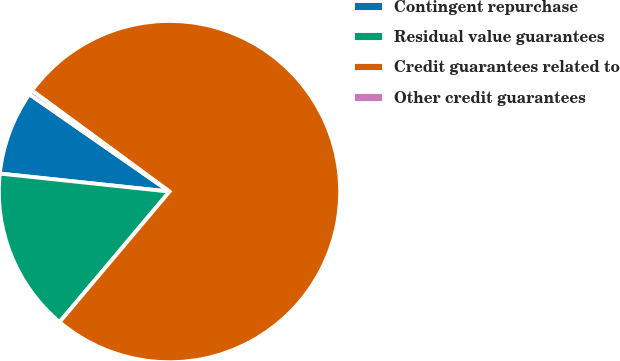Convert chart to OTSL. <chart><loc_0><loc_0><loc_500><loc_500><pie_chart><fcel>Contingent repurchase<fcel>Residual value guarantees<fcel>Credit guarantees related to<fcel>Other credit guarantees<nl><fcel>7.98%<fcel>15.54%<fcel>76.06%<fcel>0.42%<nl></chart> 